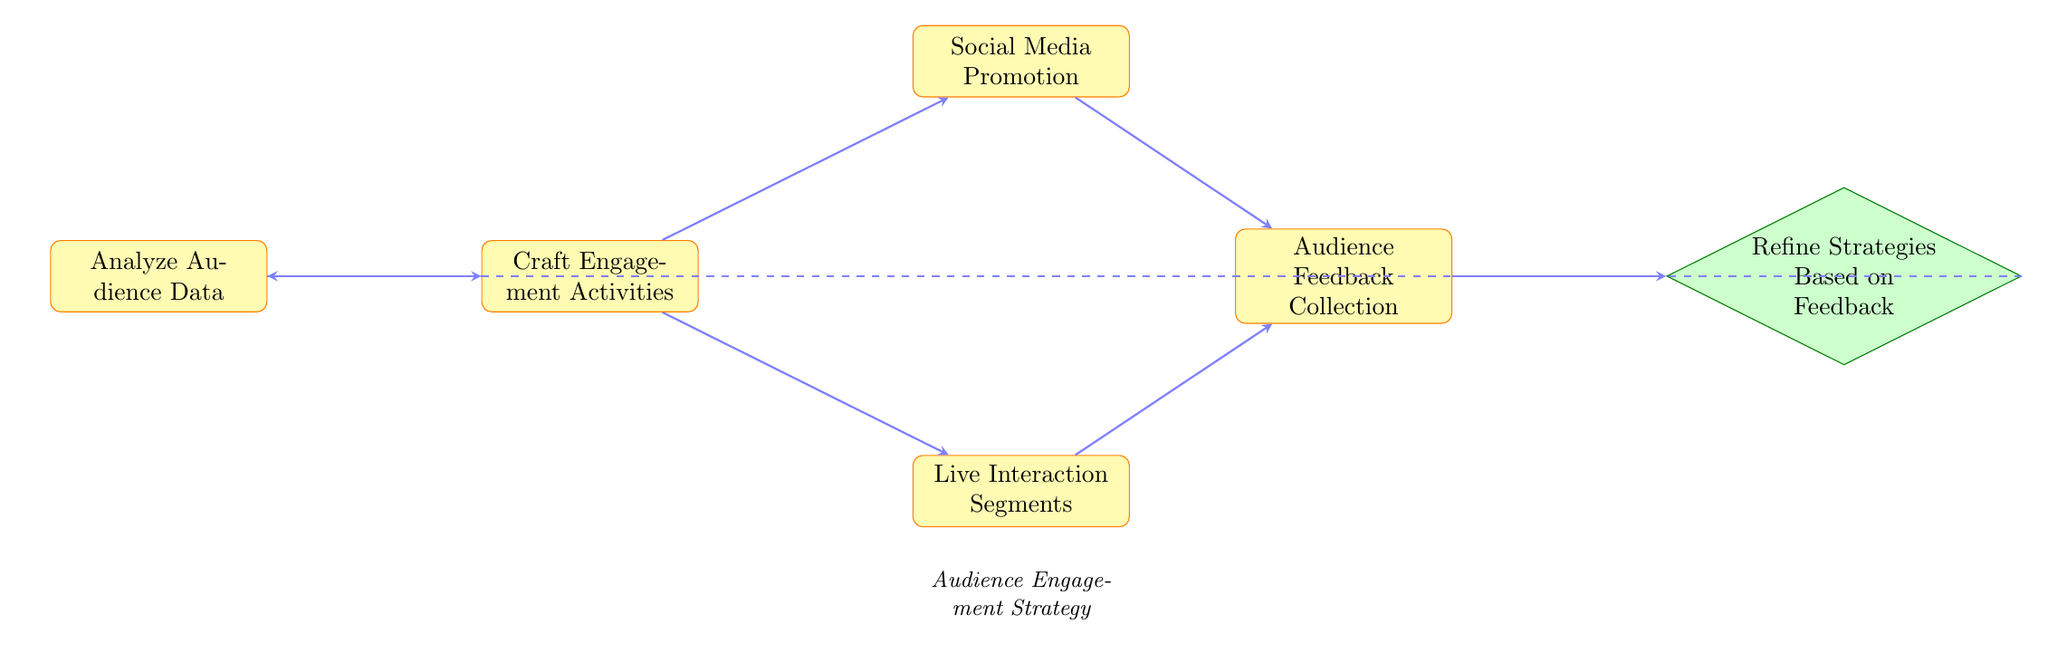What is the first step in the audience engagement strategy? The first step in the flow chart is to analyze audience data, as indicated by the initial node in the diagram.
Answer: Analyze Audience Data How many engagement activities can be crafted? The diagram shows one node for crafting engagement activities, which leads to two subsequent options, thus indicating that two different types of activities can be crafted.
Answer: Two Which two activities can be crafted after the analysis of audience data? After analyzing audience data, the flow chart shows two specific activities: social media promotion and live interaction segments. Both are connected to the crafting engagement activities node.
Answer: Social Media Promotion, Live Interaction Segments What comes after audience feedback collection? Following audience feedback collection, the next step is to refine strategies based on the feedback received, as shown by the connecting arrow in the diagram.
Answer: Refine Strategies Based on Feedback What is the relationship between social media promotion and audience feedback collection? The diagram illustrates that social media promotion leads directly to audience feedback collection, indicating that feedback is gathered following the promotional activity.
Answer: Directly connected What is the total number of nodes in the flow chart? The flow chart includes six distinct nodes, which comprise analysis, crafting activities, promotional strategies, audience interaction, feedback collection, and strategy refinement.
Answer: Six What is the role of the "craft engagement activities" node? The "craft engagement activities" node serves as a pivotal step, providing two pathways for engagement methods: social media promotion and live interaction segments, thus showcasing its importance in the process flow.
Answer: Creative Development How does audience feedback influence the overall strategy? Audience feedback collection is essential as it feeds into refining strategies, thus indicating a cyclic approach where feedback directly influences future engagement strategies. This is represented by the arrows looping back to the first node after refinement.
Answer: Refines strategies based on feedback 